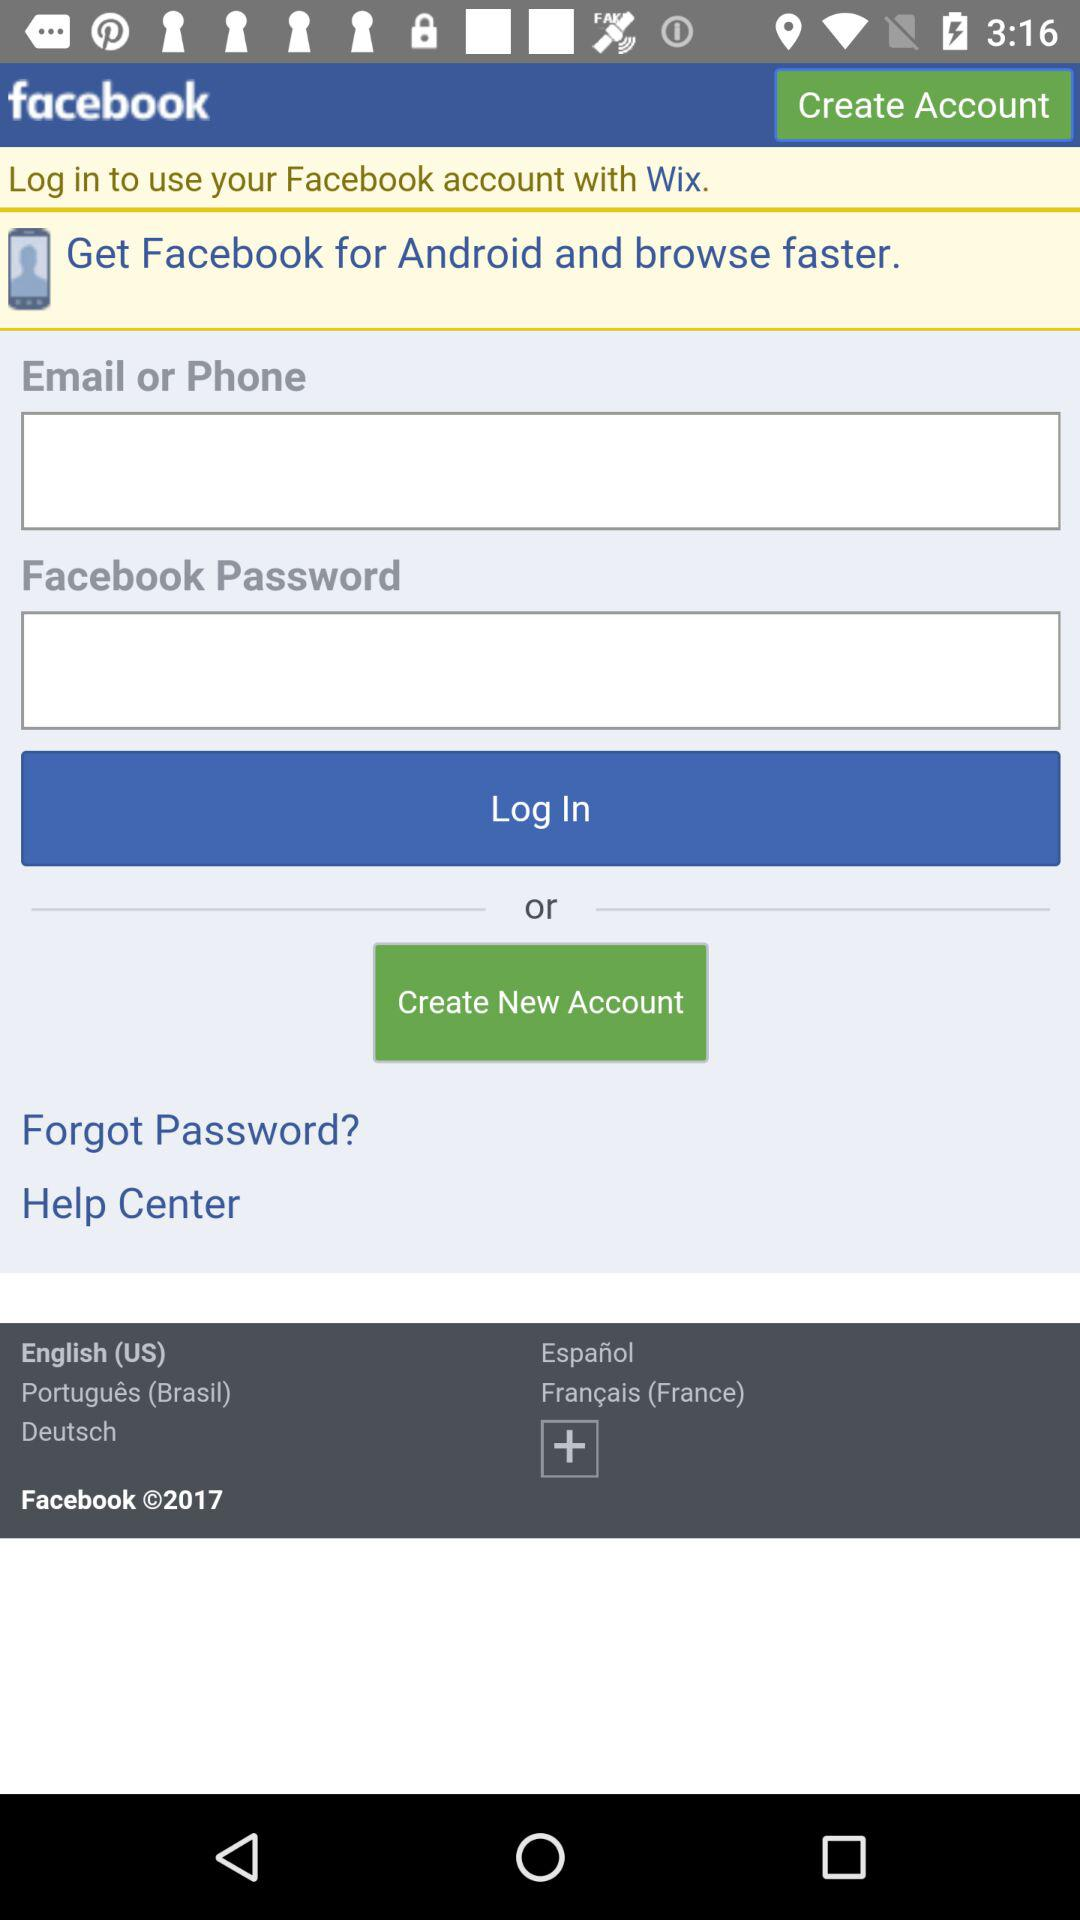Can we reset password?
When the provided information is insufficient, respond with <no answer>. <no answer> 